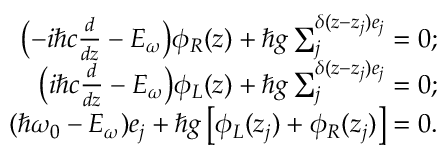Convert formula to latex. <formula><loc_0><loc_0><loc_500><loc_500>\begin{array} { r l r } & { \left ( { - i \hbar { c } \frac { d } { d z } - { E _ { \omega } } } \right ) { \phi _ { R } } ( z ) + \hbar { g } \sum _ { j } ^ { \delta ( z - { z _ { j } } ) { e _ { j } } } = 0 ; } \\ & { \left ( { i \hbar { c } \frac { d } { d z } - { E _ { \omega } } } \right ) { \phi _ { L } } ( z ) + \hbar { g } \sum _ { j } ^ { \delta ( z - { z _ { j } } ) { e _ { j } } } = 0 ; } \\ & { ( \hbar { \omega _ { 0 } } - { E _ { \omega } } ) { e _ { j } } + \hbar { g } \left [ { { \phi _ { L } } ( { z _ { j } } ) + { \phi _ { R } } ( { z _ { j } } ) } \right ] = 0 . } \end{array}</formula> 